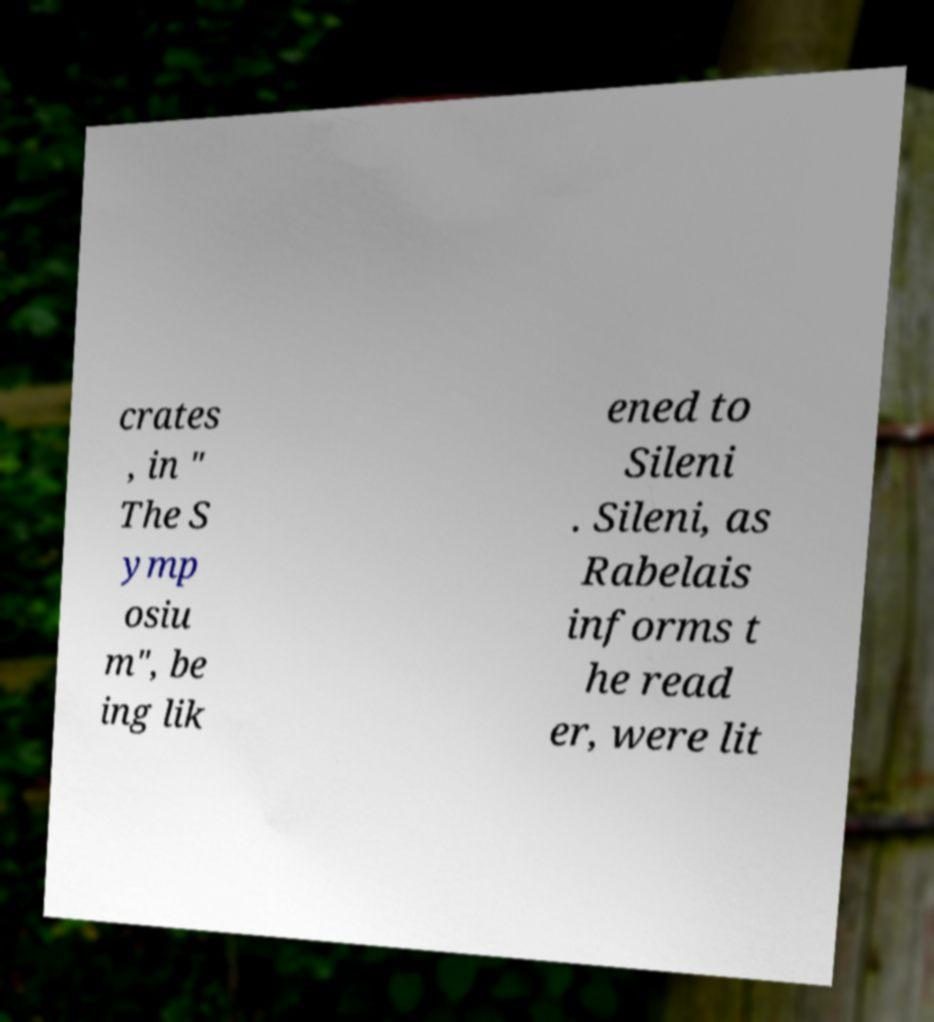Can you accurately transcribe the text from the provided image for me? crates , in " The S ymp osiu m", be ing lik ened to Sileni . Sileni, as Rabelais informs t he read er, were lit 